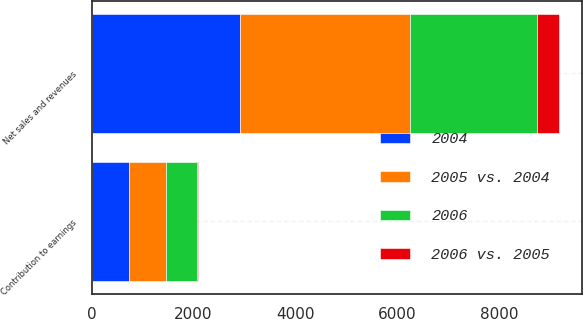<chart> <loc_0><loc_0><loc_500><loc_500><stacked_bar_chart><ecel><fcel>Net sales and revenues<fcel>Contribution to earnings<nl><fcel>2005 vs. 2004<fcel>3335<fcel>723<nl><fcel>2004<fcel>2915<fcel>734<nl><fcel>2006<fcel>2495<fcel>610<nl><fcel>2006 vs. 2005<fcel>420<fcel>11<nl></chart> 